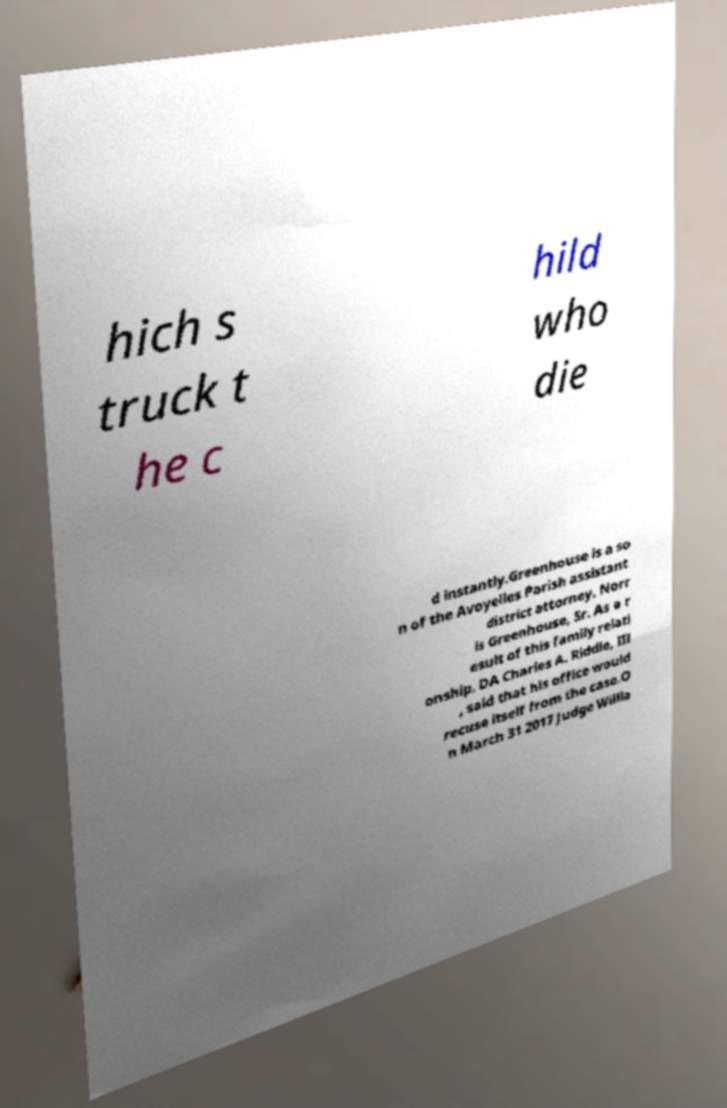Please read and relay the text visible in this image. What does it say? hich s truck t he c hild who die d instantly.Greenhouse is a so n of the Avoyelles Parish assistant district attorney, Norr is Greenhouse, Sr. As a r esult of this family relati onship, DA Charles A. Riddle, III , said that his office would recuse itself from the case.O n March 31 2017 Judge Willia 